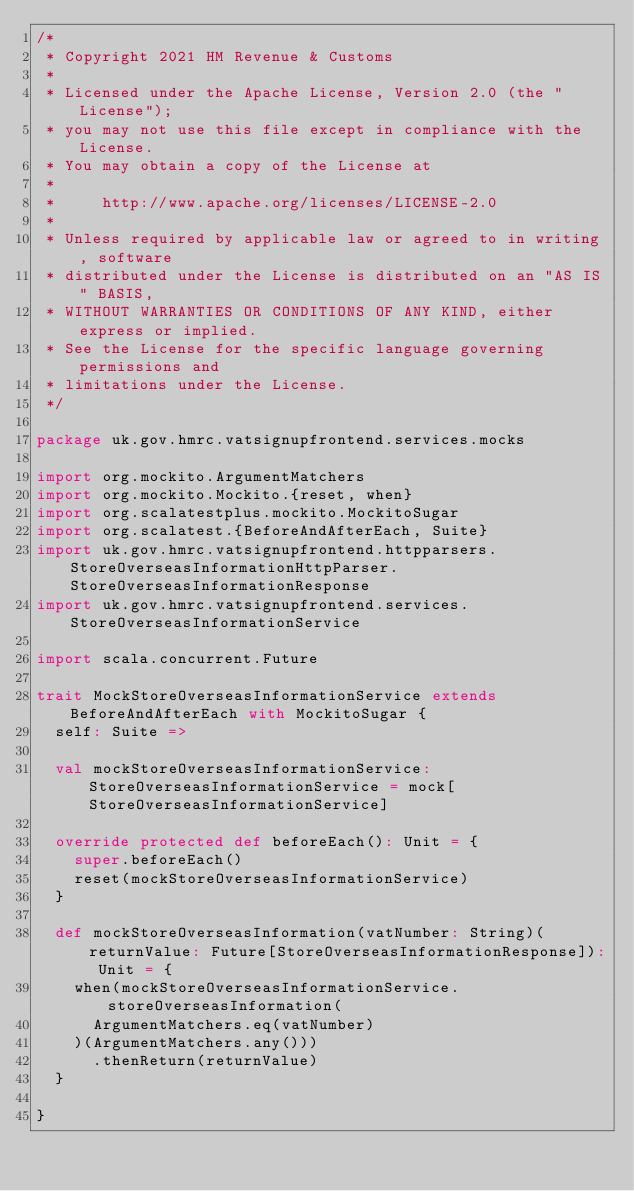Convert code to text. <code><loc_0><loc_0><loc_500><loc_500><_Scala_>/*
 * Copyright 2021 HM Revenue & Customs
 *
 * Licensed under the Apache License, Version 2.0 (the "License");
 * you may not use this file except in compliance with the License.
 * You may obtain a copy of the License at
 *
 *     http://www.apache.org/licenses/LICENSE-2.0
 *
 * Unless required by applicable law or agreed to in writing, software
 * distributed under the License is distributed on an "AS IS" BASIS,
 * WITHOUT WARRANTIES OR CONDITIONS OF ANY KIND, either express or implied.
 * See the License for the specific language governing permissions and
 * limitations under the License.
 */

package uk.gov.hmrc.vatsignupfrontend.services.mocks

import org.mockito.ArgumentMatchers
import org.mockito.Mockito.{reset, when}
import org.scalatestplus.mockito.MockitoSugar
import org.scalatest.{BeforeAndAfterEach, Suite}
import uk.gov.hmrc.vatsignupfrontend.httpparsers.StoreOverseasInformationHttpParser.StoreOverseasInformationResponse
import uk.gov.hmrc.vatsignupfrontend.services.StoreOverseasInformationService

import scala.concurrent.Future

trait MockStoreOverseasInformationService extends BeforeAndAfterEach with MockitoSugar {
  self: Suite =>

  val mockStoreOverseasInformationService: StoreOverseasInformationService = mock[StoreOverseasInformationService]

  override protected def beforeEach(): Unit = {
    super.beforeEach()
    reset(mockStoreOverseasInformationService)
  }

  def mockStoreOverseasInformation(vatNumber: String)(returnValue: Future[StoreOverseasInformationResponse]): Unit = {
    when(mockStoreOverseasInformationService.storeOverseasInformation(
      ArgumentMatchers.eq(vatNumber)
    )(ArgumentMatchers.any()))
      .thenReturn(returnValue)
  }

}
</code> 